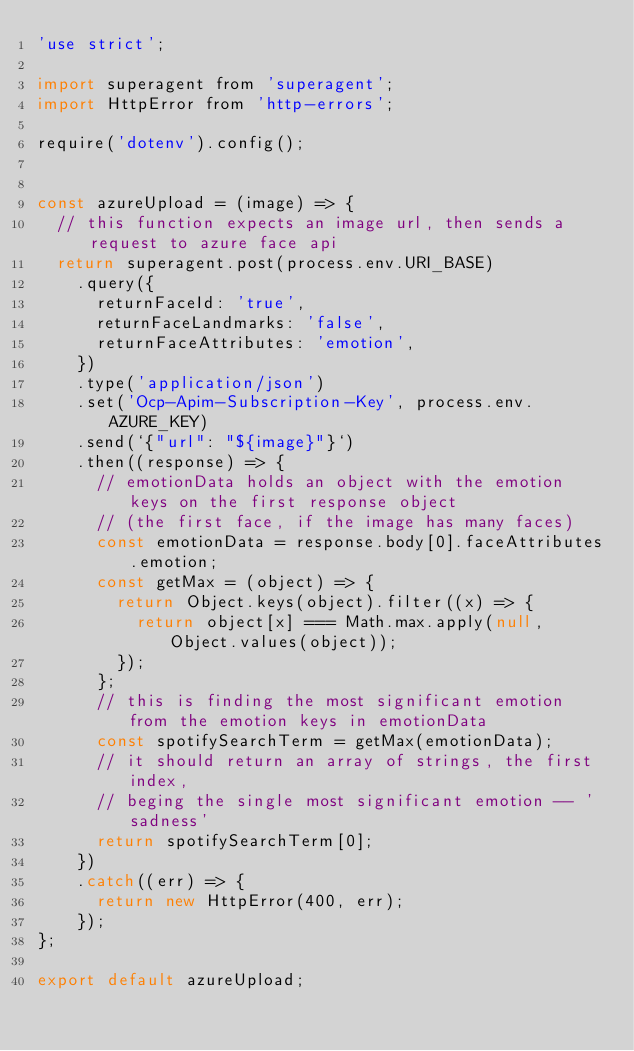Convert code to text. <code><loc_0><loc_0><loc_500><loc_500><_JavaScript_>'use strict';

import superagent from 'superagent';
import HttpError from 'http-errors';

require('dotenv').config();


const azureUpload = (image) => {
  // this function expects an image url, then sends a request to azure face api
  return superagent.post(process.env.URI_BASE)
    .query({ 
      returnFaceId: 'true',
      returnFaceLandmarks: 'false',
      returnFaceAttributes: 'emotion',
    })
    .type('application/json')
    .set('Ocp-Apim-Subscription-Key', process.env.AZURE_KEY)
    .send(`{"url": "${image}"}`)
    .then((response) => {
      // emotionData holds an object with the emotion keys on the first response object 
      // (the first face, if the image has many faces)
      const emotionData = response.body[0].faceAttributes.emotion;
      const getMax = (object) => {
        return Object.keys(object).filter((x) => {
          return object[x] === Math.max.apply(null, Object.values(object));
        });
      };
      // this is finding the most significant emotion from the emotion keys in emotionData
      const spotifySearchTerm = getMax(emotionData);
      // it should return an array of strings, the first index, 
      // beging the single most significant emotion -- 'sadness'
      return spotifySearchTerm[0];
    })
    .catch((err) => {
      return new HttpError(400, err);
    });
};

export default azureUpload;
</code> 